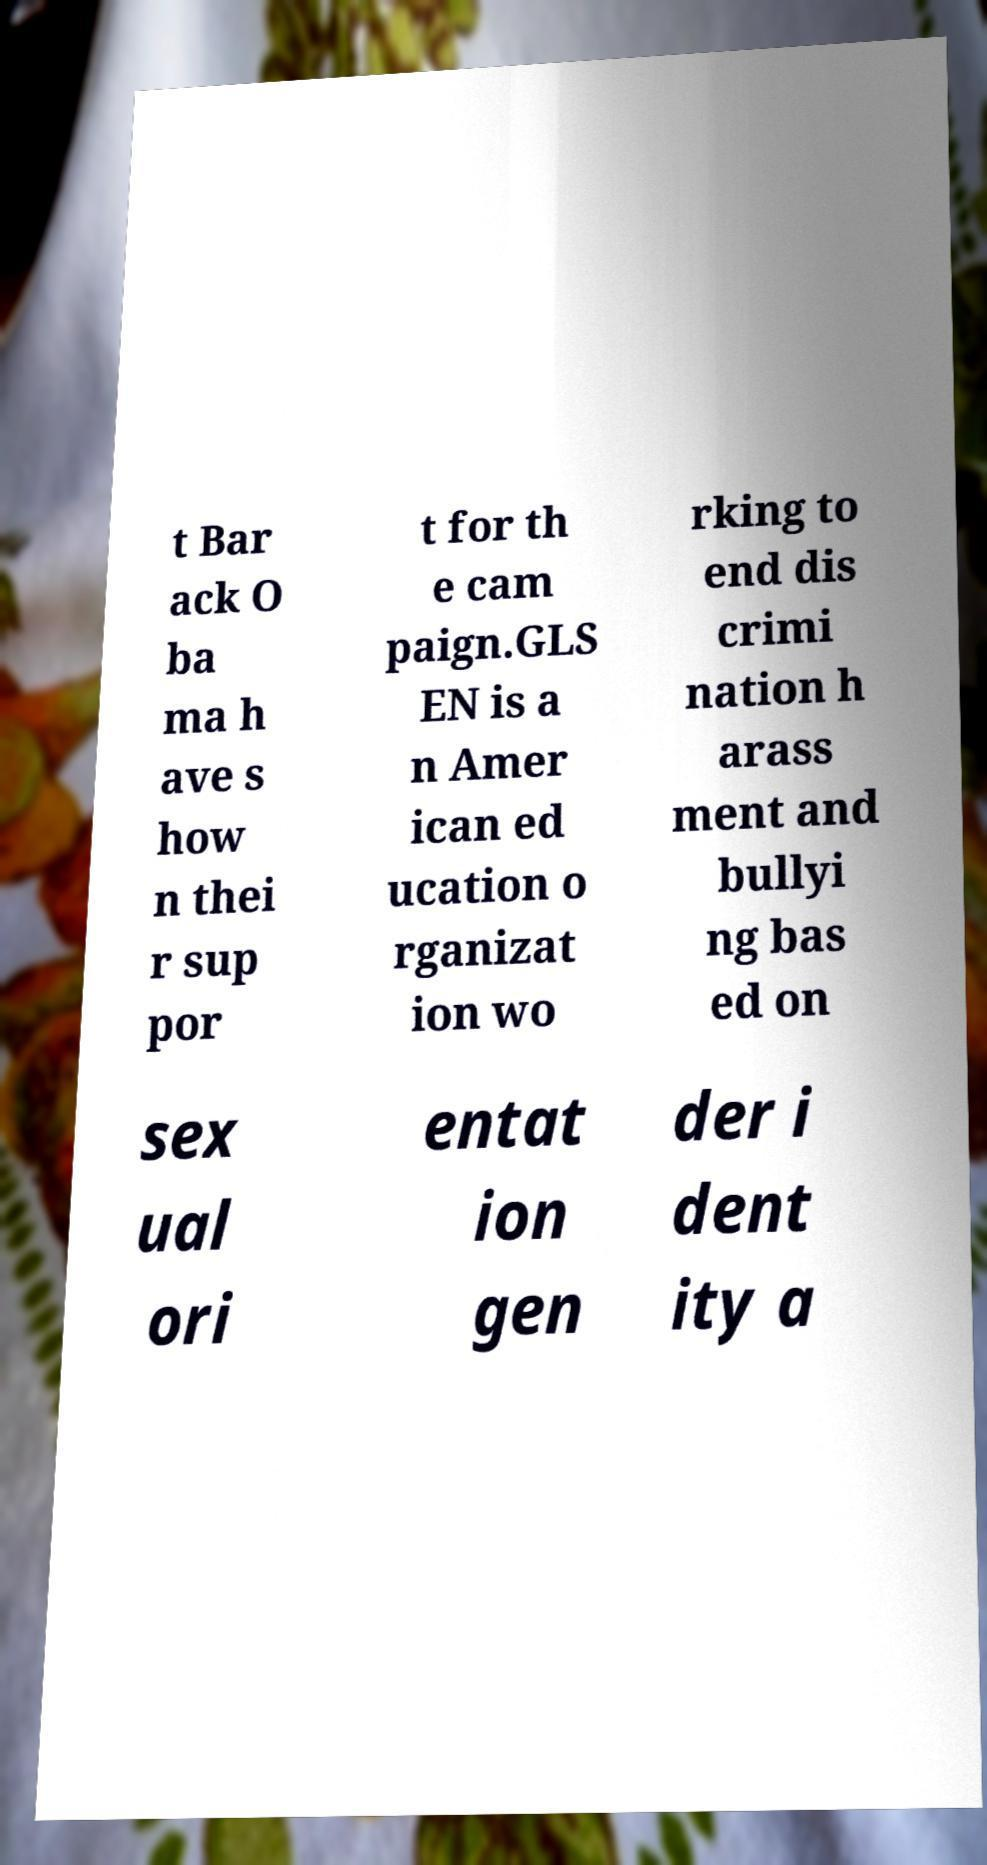I need the written content from this picture converted into text. Can you do that? t Bar ack O ba ma h ave s how n thei r sup por t for th e cam paign.GLS EN is a n Amer ican ed ucation o rganizat ion wo rking to end dis crimi nation h arass ment and bullyi ng bas ed on sex ual ori entat ion gen der i dent ity a 